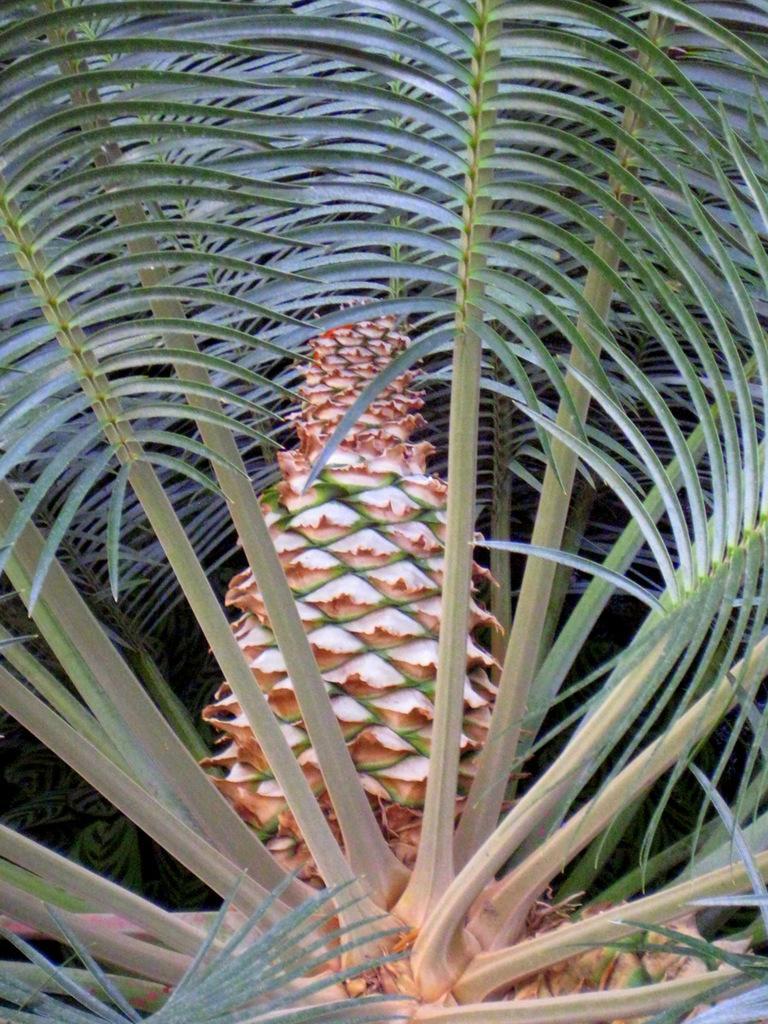Could you give a brief overview of what you see in this image? In this picture I can see the plant. 